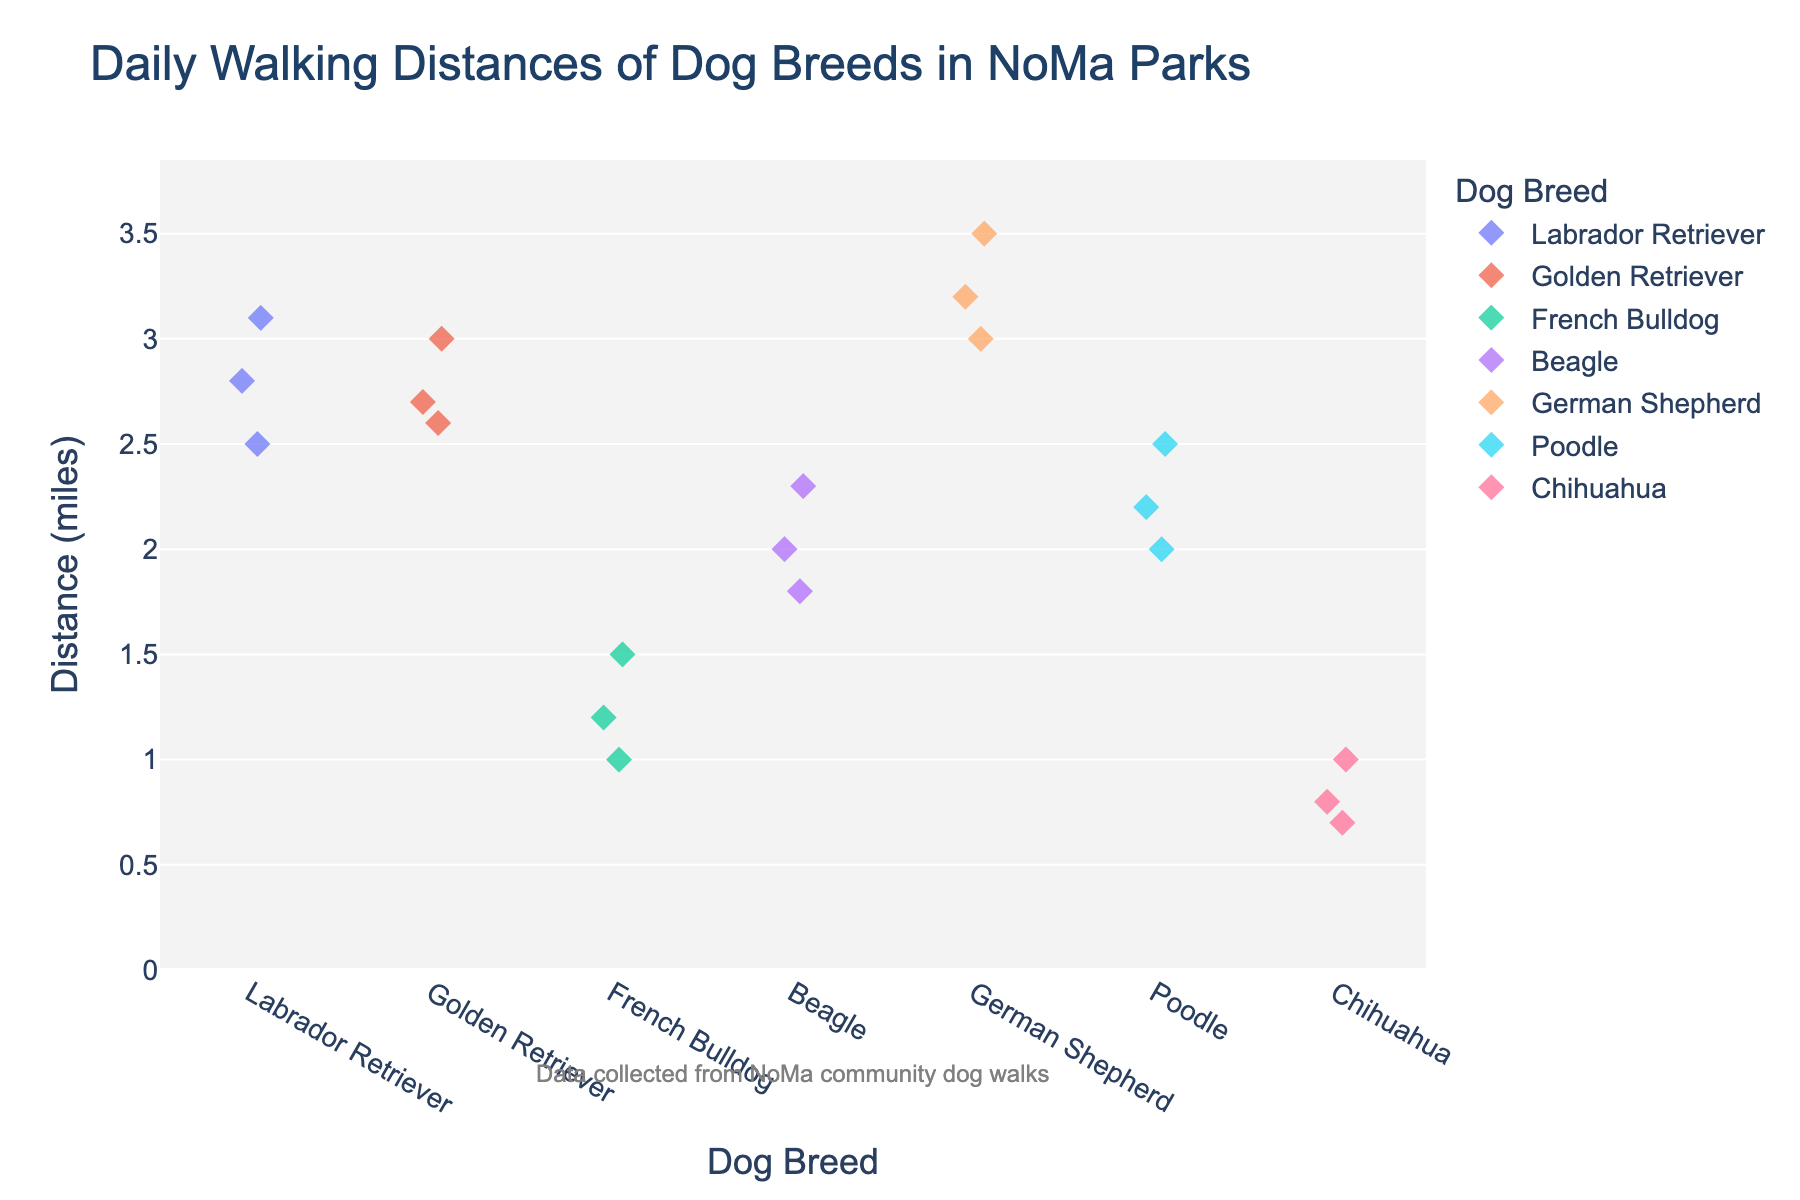How many different dog breeds are represented in the plot? The plot shows distinct colored markers for each breed. Counting these different colors or names on the x-axis will give the total number of breeds.
Answer: 6 What is the maximum walking distance for Labrador Retrievers? Identify the markers for Labrador Retrievers and find the one positioned highest on the y-axis, which represents the greatest distance.
Answer: 3.1 miles Which breed has the smallest walking distances? Observe the markers plotted lowest on the y-axis and identify which breed they belong to.
Answer: Chihuahua What's the difference in the maximum walking distances between German Shepherds and Chihuahuas? Identify the highest marker for German Shepherds (3.5 miles) and the highest for Chihuahuas (1.0 miles). Subtract the two to get the difference.
Answer: 2.5 miles What is the average walking distance for Beagles? Locate the markers for Beagles and note their y-values (2.0, 2.3, 1.8). Sum these values (2.0 + 2.3 + 1.8 = 6.1) and divide by the number of data points (3).
Answer: 2.03 miles Which breed shows the most variability in walking distances? Observe the spread or dispersion of the markers for each breed. The breed with the widest spread of markers has the most variability.
Answer: Labrador Retriever How many data points are there for Golden Retrievers? Count the number of markers plotted for Golden Retrievers.
Answer: 3 Which breeds have at least one dog walking more than 3 miles daily? Identify which breeds have markers above the 3 miles mark on the y-axis.
Answer: Labrador Retriever, Golden Retriever, German Shepherd What is the median walking distance for Poodles? Arrange the walking distances for Poodles (2.0, 2.2, 2.5) in ascending order and find the middle value.
Answer: 2.2 miles Compare the average walking distance of French Bulldogs with that of Beagles. Which breed walks more on average? Calculate the average walking distance for French Bulldogs (1.2, 1.5, 1.0) which is (1.2 + 1.5 + 1.0) / 3 = 1.23 miles. Compare this with the average distance for Beagles already calculated as 2.03 miles.
Answer: Beagles 